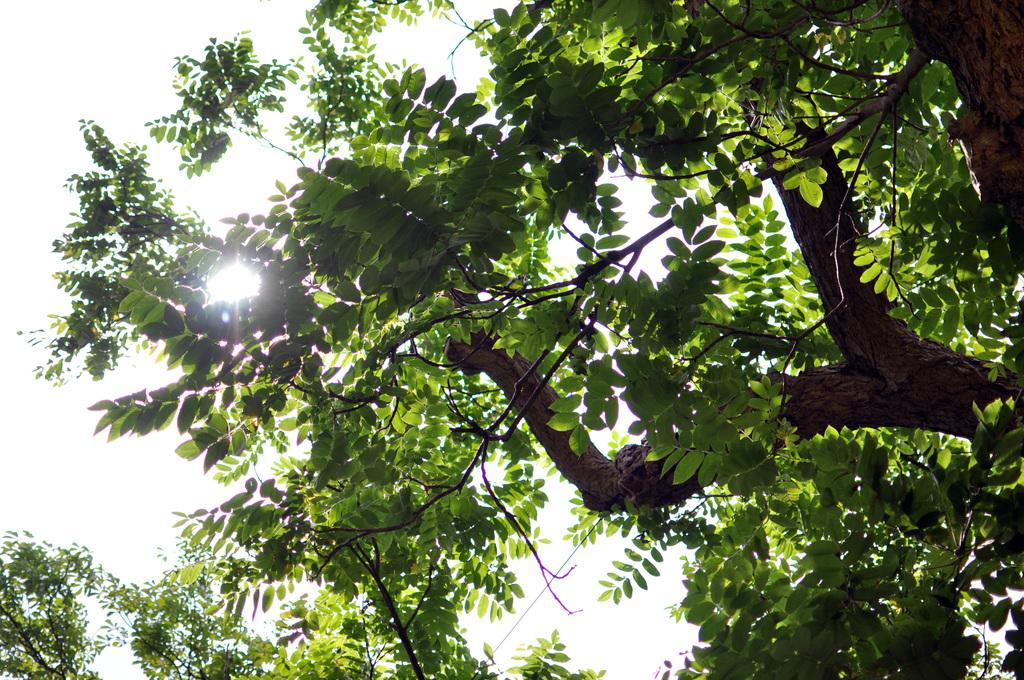What is the main object in the image? There is a tree in the image. What can be observed about the tree's appearance? The tree has leaves. What can be seen in the background of the image? The sky is visible in the background of the image. How would you describe the sky's condition? The sky is clear. How many matches are hanging from the tree in the image? There are no matches present in the image; it features a tree with leaves. What type of apple can be seen growing on the tree in the image? There is no apple present on the tree in the image; it only has leaves. 